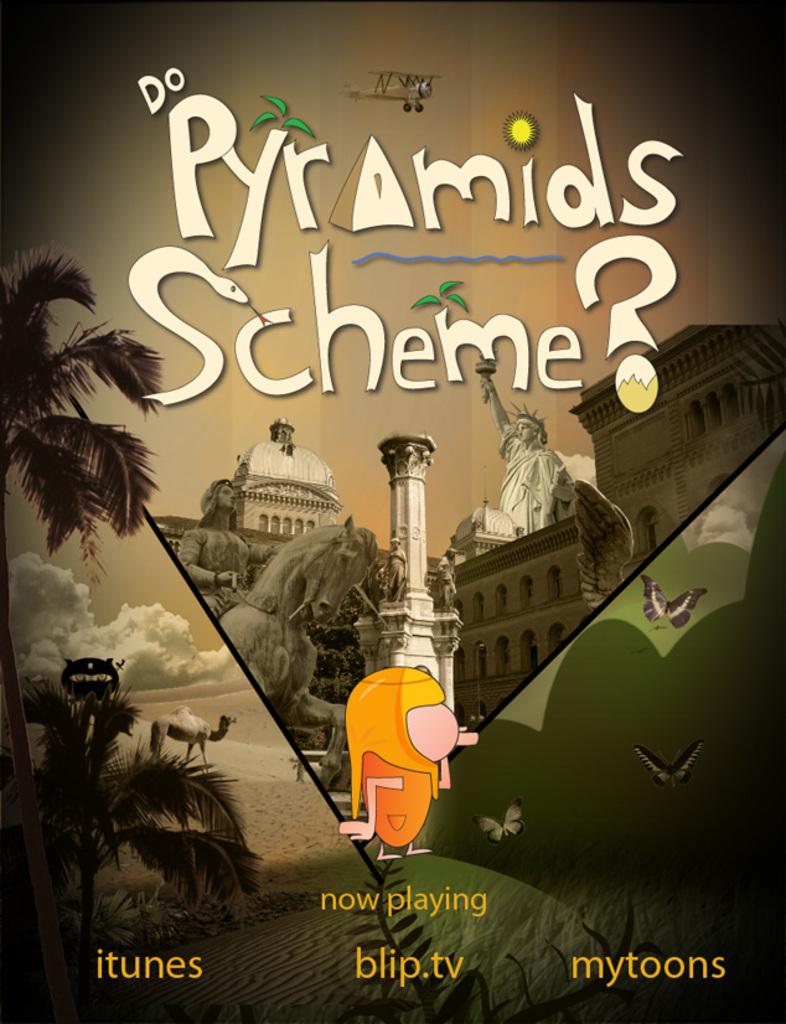What is the title of this?
Ensure brevity in your answer.  Do pyramids scheme?. Where can you find this?
Your response must be concise. Itunes blip.tv mytoons. 